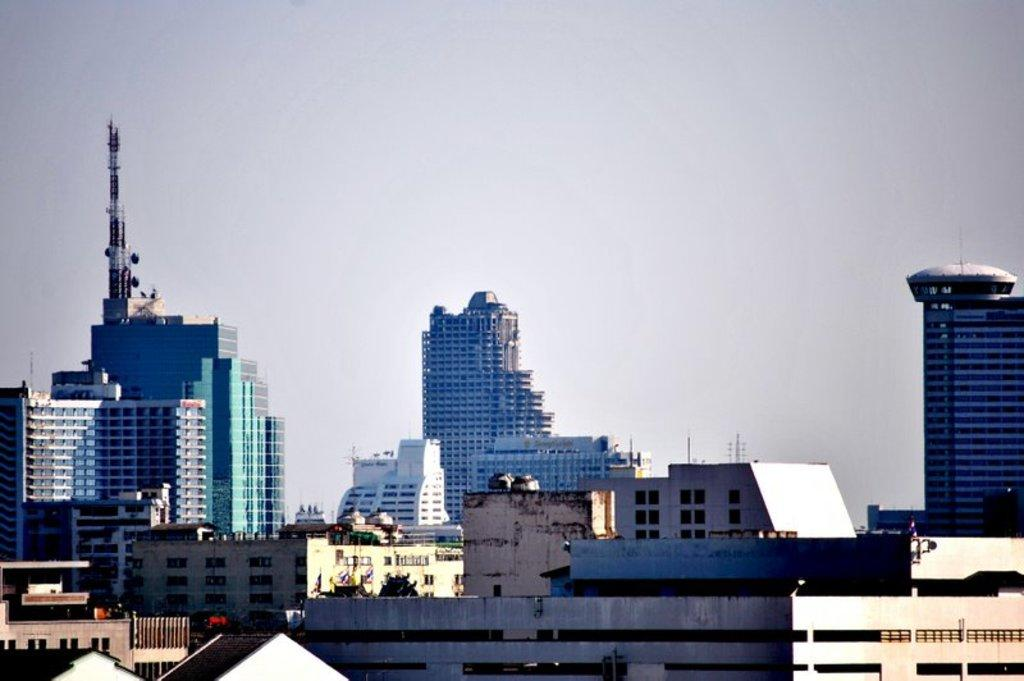What type of structures are present in the image? There are buildings in the image. What feature do the buildings have in common? The buildings have glass windows and glass doors. What is the condition of the sky in the image? The sky is clear in the image. What type of form can be seen copying the buildings in the image? There is no form or copying activity present in the image; it features buildings with glass windows and doors. 